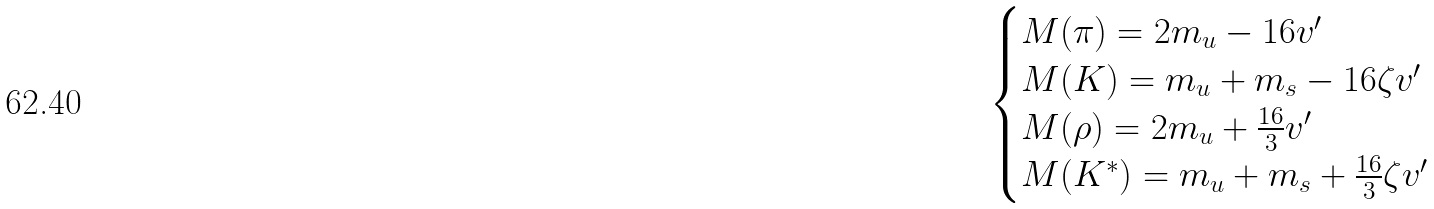<formula> <loc_0><loc_0><loc_500><loc_500>\begin{cases} M ( \pi ) = 2 m _ { u } - 1 6 v ^ { \prime } & \\ M ( K ) = m _ { u } + m _ { s } - 1 6 \zeta v ^ { \prime } & \\ M ( \rho ) = 2 m _ { u } + \frac { 1 6 } { 3 } v ^ { \prime } & \\ M ( K ^ { * } ) = m _ { u } + m _ { s } + \frac { 1 6 } { 3 } \zeta v ^ { \prime } & \\ \end{cases}</formula> 